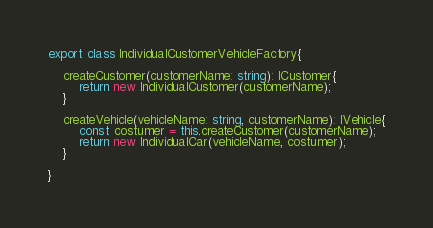Convert code to text. <code><loc_0><loc_0><loc_500><loc_500><_TypeScript_>
export class IndividualCustomerVehicleFactory{

    createCustomer(customerName: string): ICustomer{
        return new IndividualCustomer(customerName);
    }

    createVehicle(vehicleName: string, customerName): IVehicle{
        const costumer = this.createCustomer(customerName);
        return new IndividualCar(vehicleName, costumer);
    }
    
}</code> 